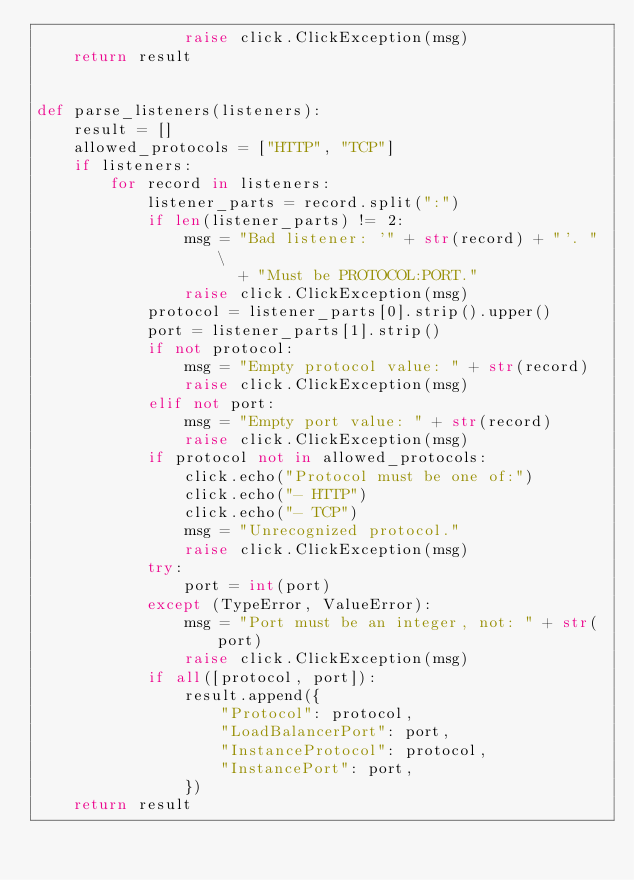<code> <loc_0><loc_0><loc_500><loc_500><_Python_>                raise click.ClickException(msg)
    return result


def parse_listeners(listeners):
    result = []
    allowed_protocols = ["HTTP", "TCP"]
    if listeners:
        for record in listeners:
            listener_parts = record.split(":")
            if len(listener_parts) != 2:
                msg = "Bad listener: '" + str(record) + "'. " \
                      + "Must be PROTOCOL:PORT."
                raise click.ClickException(msg)
            protocol = listener_parts[0].strip().upper()
            port = listener_parts[1].strip()
            if not protocol:
                msg = "Empty protocol value: " + str(record)
                raise click.ClickException(msg)
            elif not port:
                msg = "Empty port value: " + str(record)
                raise click.ClickException(msg)
            if protocol not in allowed_protocols:
                click.echo("Protocol must be one of:")
                click.echo("- HTTP")
                click.echo("- TCP")
                msg = "Unrecognized protocol."
                raise click.ClickException(msg)
            try:
                port = int(port)
            except (TypeError, ValueError):
                msg = "Port must be an integer, not: " + str(port)
                raise click.ClickException(msg)
            if all([protocol, port]):
                result.append({
                    "Protocol": protocol,
                    "LoadBalancerPort": port,
                    "InstanceProtocol": protocol,
                    "InstancePort": port,
                })
    return result
</code> 